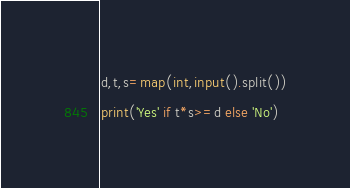Convert code to text. <code><loc_0><loc_0><loc_500><loc_500><_Python_>d,t,s=map(int,input().split())
print('Yes' if t*s>=d else 'No')
</code> 